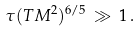Convert formula to latex. <formula><loc_0><loc_0><loc_500><loc_500>\tau ( T M ^ { 2 } ) ^ { 6 / 5 } \, \gg \, 1 \, .</formula> 